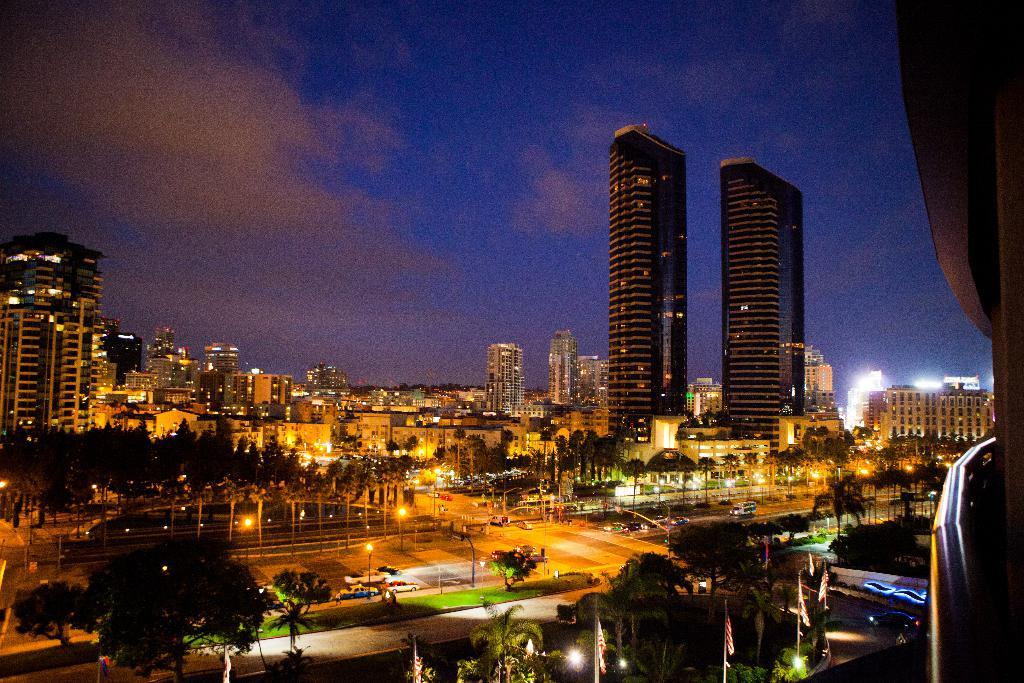What type of structures can be seen in the image? There are buildings in the image. What else can be seen in the image besides buildings? There are trees, vehicles on the roads, street lights, and other objects in the image. Can you describe the roads in the image? The roads have vehicles on them. What is visible in the background of the image? The sky is visible in the background of the image. What type of leather is used to make the clocks in the image? There are no clocks present in the image, so it is not possible to determine what type of leather might be used. 